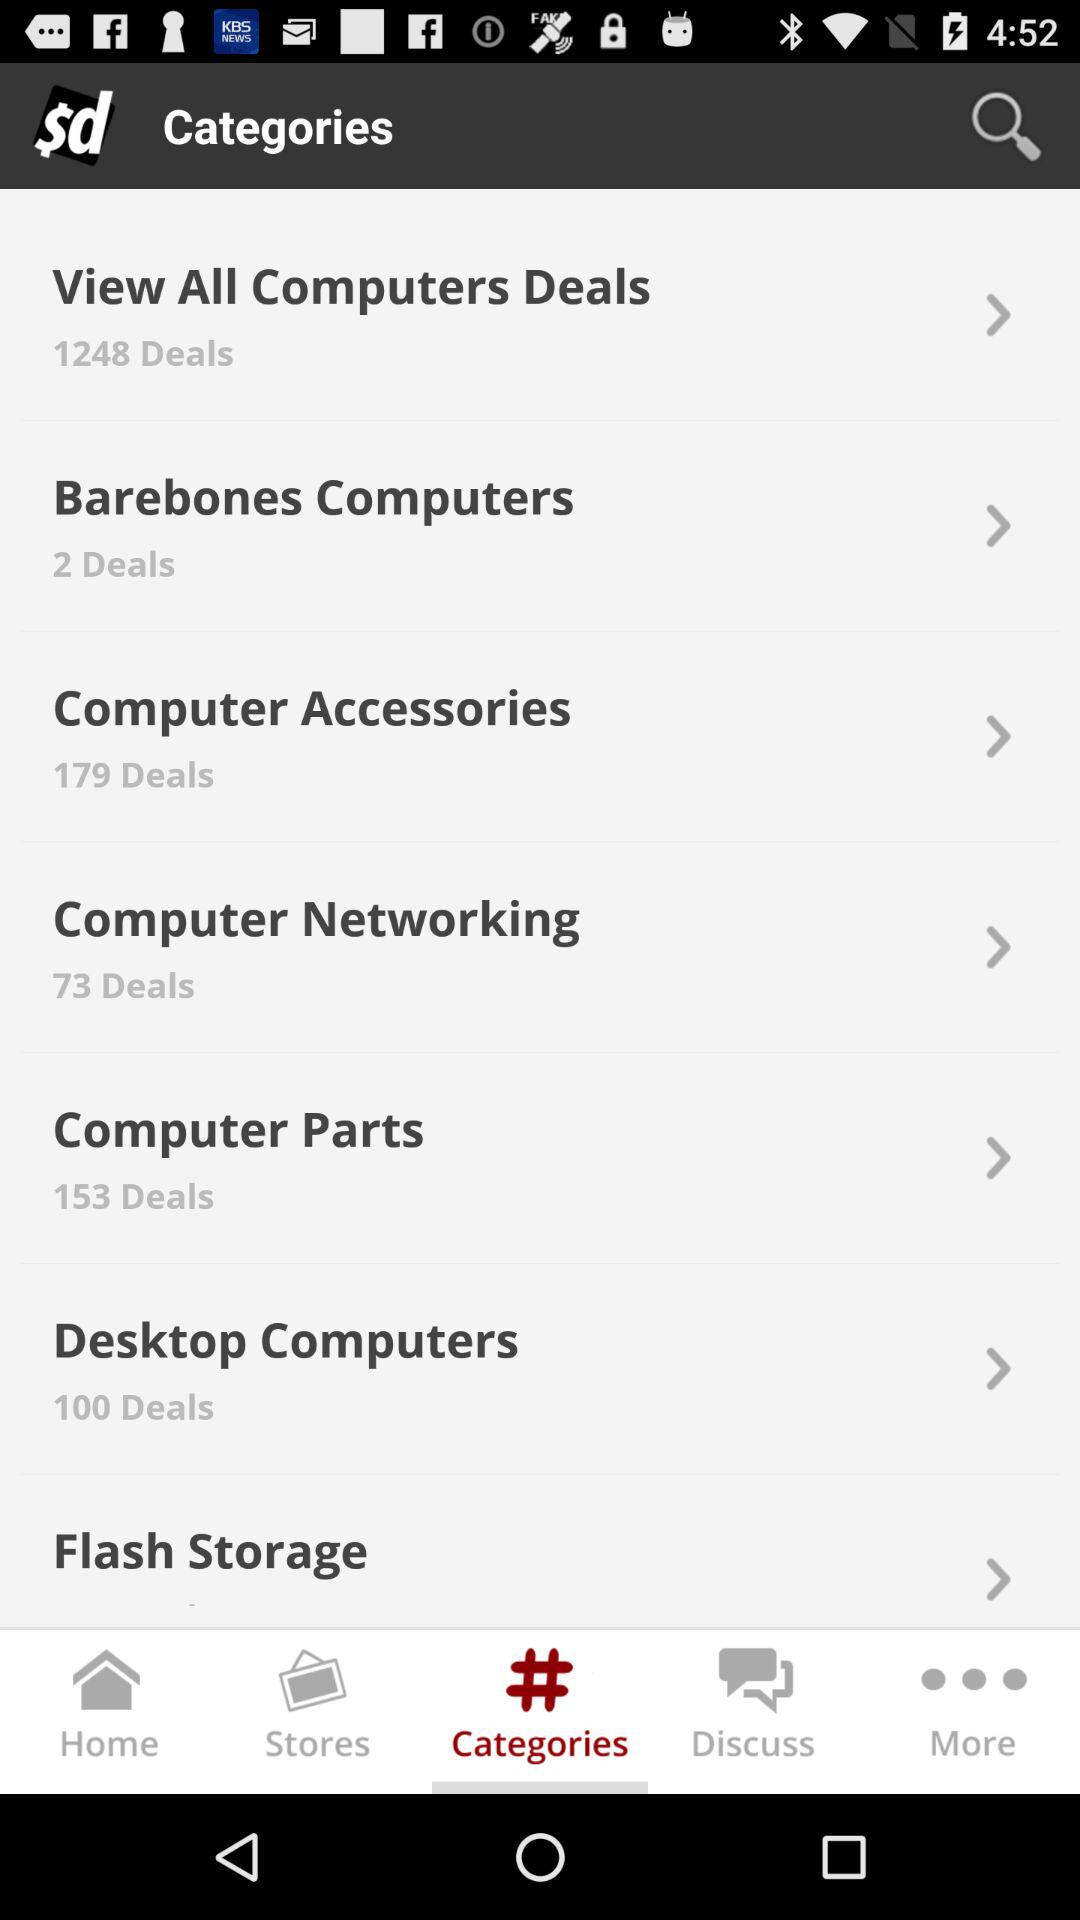How many deals are there in "View All Computers Deals"? There are 1248 deals. 